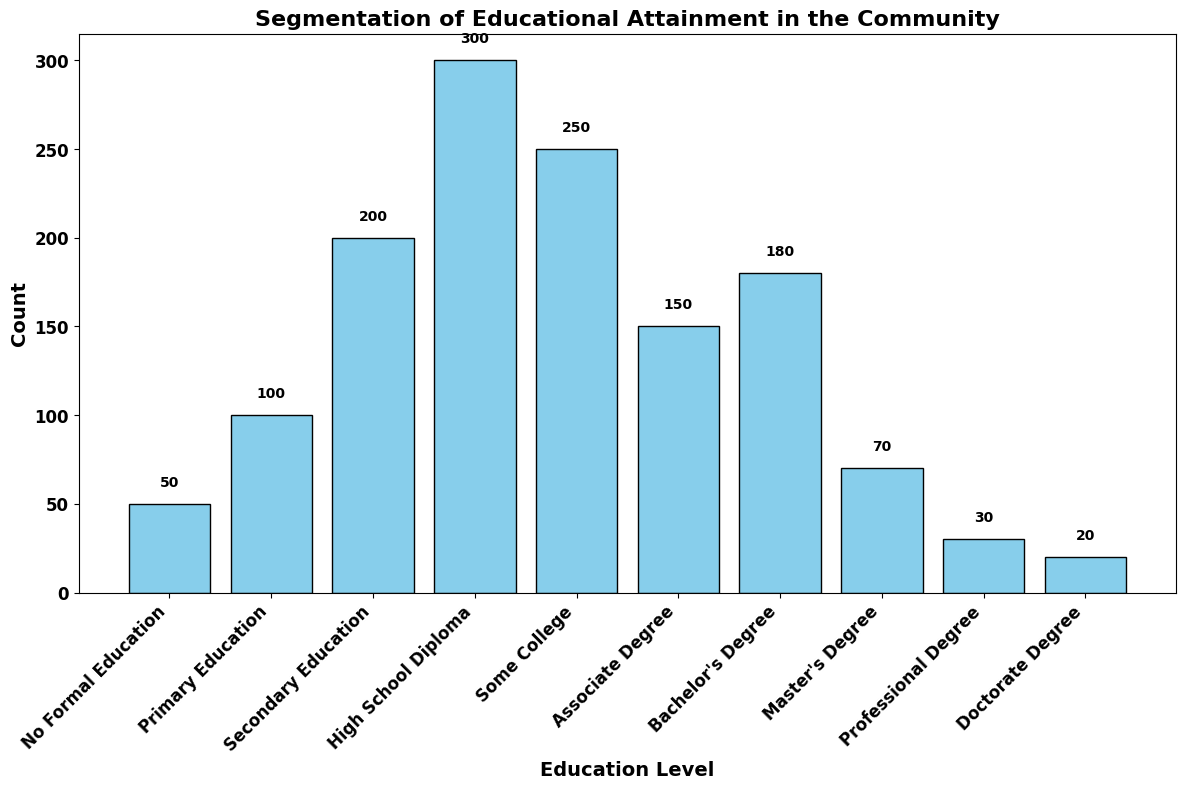What is the total number of people with 'Secondary Education' and 'High School Diploma'? Add the counts for 'Secondary Education' (200) and 'High School Diploma' (300): 200 + 300 = 500
Answer: 500 What is the difference in count between those with 'Bachelor's Degree' and 'Associate Degree'? Subtract the count for 'Associate Degree' (150) from 'Bachelor's Degree' (180): 180 - 150 = 30
Answer: 30 Which education level has the highest count? Identify the education level with the tallest bar on the histogram, which is labeled 'High School Diploma' with a count of 300
Answer: High School Diploma How many more people have 'Primary Education' compared to 'No Formal Education'? Subtract the count for 'No Formal Education' (50) from 'Primary Education' (100): 100 - 50 = 50
Answer: 50 What is the median count of educational attainment levels? Sort the counts and identify the middle value(s). The counts in ascending order are: 20, 30, 50, 70, 100, 150, 180, 200, 250, 300. The median values are the 5th and 6th counts: (100 + 150)/2 = 125
Answer: 125 Which education levels have more than 200 people? Identify bars on the histogram with heights greater than 200: 'High School Diploma' (300) and 'Some College' (250) count more than 200
Answer: High School Diploma, Some College How many people have postgraduate degrees combined ('Master's Degree,' 'Professional Degree,' 'Doctorate Degree')? Add the counts for 'Master's Degree' (70), 'Professional Degree' (30), and 'Doctorate Degree' (20): 70 + 30 + 20 = 120
Answer: 120 What is the approximate height difference between the bars for 'Primary Education' and 'Some College'? Subtract the count for 'Primary Education' (100) from 'Some College' (250): 250 - 100 = 150
Answer: 150 How many educational levels have fewer than 100 people? Count the bars on the histogram with heights less than 100: 'No Formal Education' (50), 'Master's Degree' (70), 'Professional Degree' (30), and 'Doctorate Degree' (20) total 4
Answer: 4 Which educational attainment has the second-lowest count? Identify the second shortest bar on the histogram, which is labeled 'Professional Degree' with a count of 30
Answer: Professional Degree 